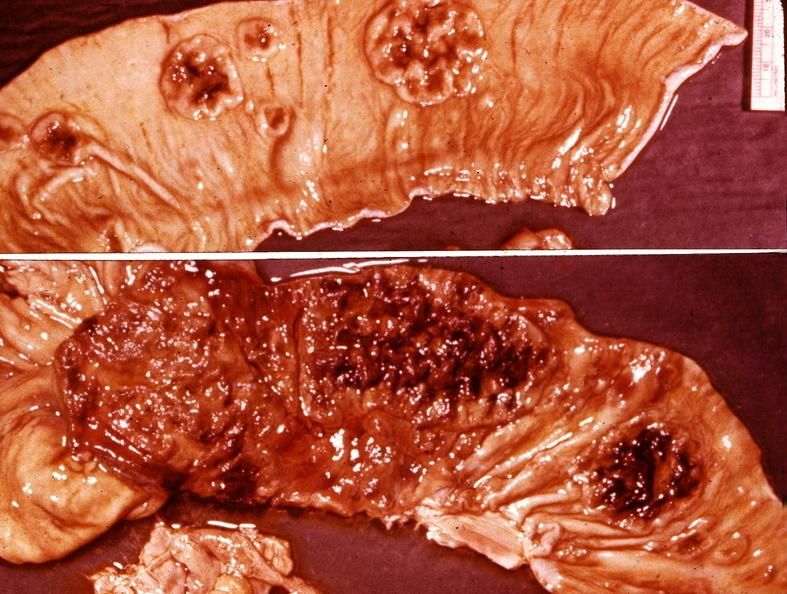s leiomyoma present?
Answer the question using a single word or phrase. No 